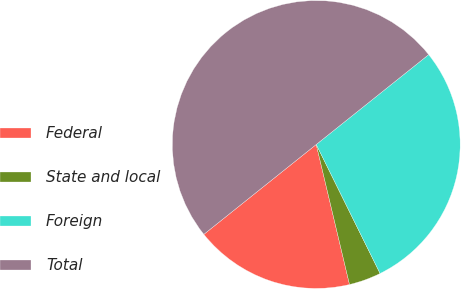Convert chart. <chart><loc_0><loc_0><loc_500><loc_500><pie_chart><fcel>Federal<fcel>State and local<fcel>Foreign<fcel>Total<nl><fcel>17.98%<fcel>3.6%<fcel>28.42%<fcel>50.0%<nl></chart> 